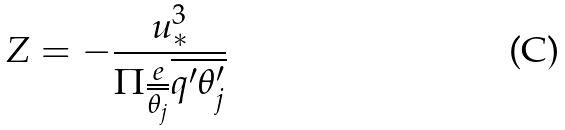Convert formula to latex. <formula><loc_0><loc_0><loc_500><loc_500>Z = - \frac { u _ { * } ^ { 3 } } { \Pi \frac { e } { \overline { \theta _ { j } } } \overline { q ^ { \prime } \theta _ { j } ^ { \prime } } }</formula> 